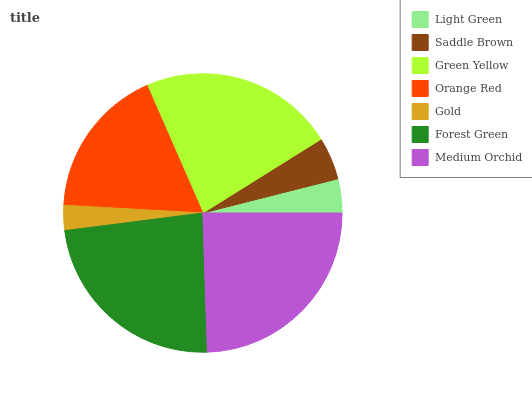Is Gold the minimum?
Answer yes or no. Yes. Is Medium Orchid the maximum?
Answer yes or no. Yes. Is Saddle Brown the minimum?
Answer yes or no. No. Is Saddle Brown the maximum?
Answer yes or no. No. Is Saddle Brown greater than Light Green?
Answer yes or no. Yes. Is Light Green less than Saddle Brown?
Answer yes or no. Yes. Is Light Green greater than Saddle Brown?
Answer yes or no. No. Is Saddle Brown less than Light Green?
Answer yes or no. No. Is Orange Red the high median?
Answer yes or no. Yes. Is Orange Red the low median?
Answer yes or no. Yes. Is Green Yellow the high median?
Answer yes or no. No. Is Gold the low median?
Answer yes or no. No. 